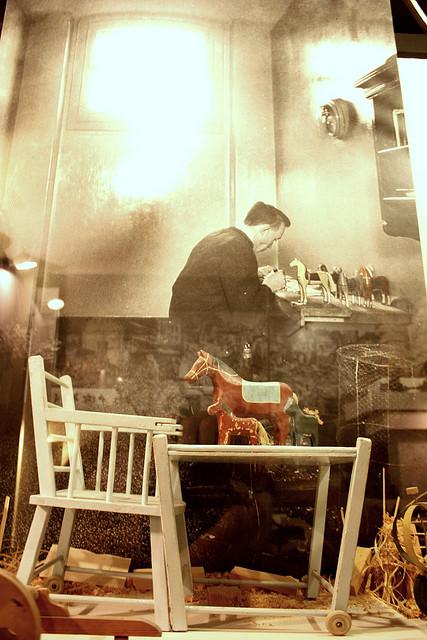How many chairs are pictured?
Short answer required. 1. Could his hobby be carving small horses?
Answer briefly. Yes. What color is the chair?
Write a very short answer. White. 